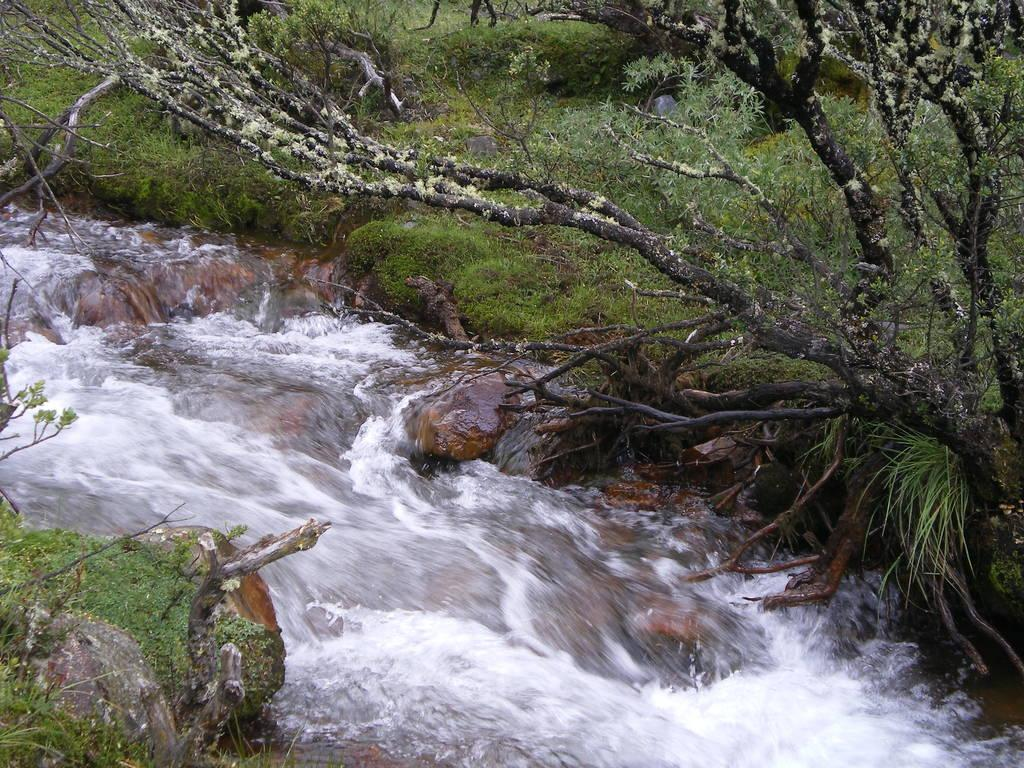What is the primary element visible in the image? There is water in the image. What other natural features can be seen in the image? There is a group of rocks in the image. What can be seen in the background of the image? There is a group of trees, plants, and grass in the background of the image. What type of quill is being used by the lawyer standing near the water in the image? There is no lawyer or quill present in the image; it features water and a group of rocks. 